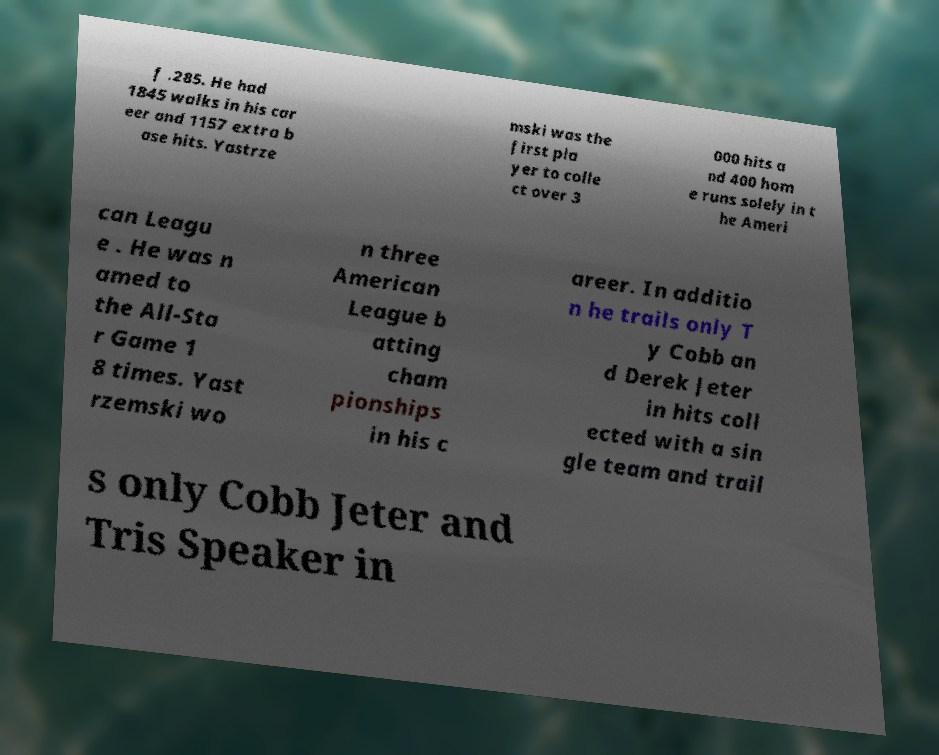Can you read and provide the text displayed in the image?This photo seems to have some interesting text. Can you extract and type it out for me? f .285. He had 1845 walks in his car eer and 1157 extra b ase hits. Yastrze mski was the first pla yer to colle ct over 3 000 hits a nd 400 hom e runs solely in t he Ameri can Leagu e . He was n amed to the All-Sta r Game 1 8 times. Yast rzemski wo n three American League b atting cham pionships in his c areer. In additio n he trails only T y Cobb an d Derek Jeter in hits coll ected with a sin gle team and trail s only Cobb Jeter and Tris Speaker in 